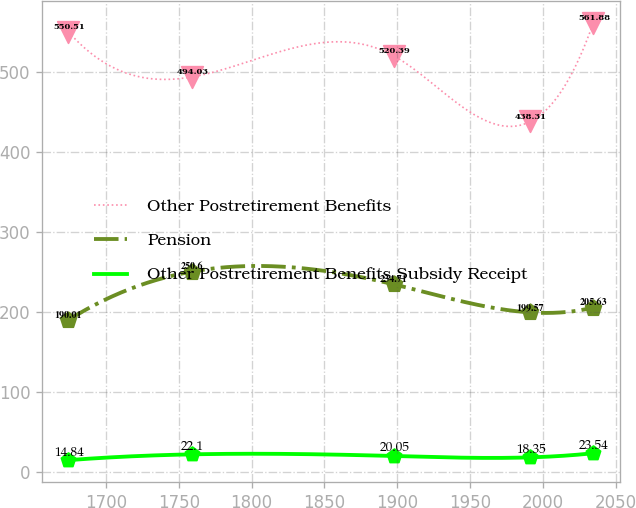Convert chart to OTSL. <chart><loc_0><loc_0><loc_500><loc_500><line_chart><ecel><fcel>Other Postretirement Benefits<fcel>Pension<fcel>Other Postretirement Benefits Subsidy Receipt<nl><fcel>1674.19<fcel>550.51<fcel>190.01<fcel>14.84<nl><fcel>1759<fcel>494.03<fcel>250.6<fcel>22.1<nl><fcel>1897.63<fcel>520.39<fcel>234.71<fcel>20.05<nl><fcel>1991.49<fcel>438.31<fcel>199.57<fcel>18.35<nl><fcel>2034.69<fcel>561.88<fcel>205.63<fcel>23.54<nl></chart> 